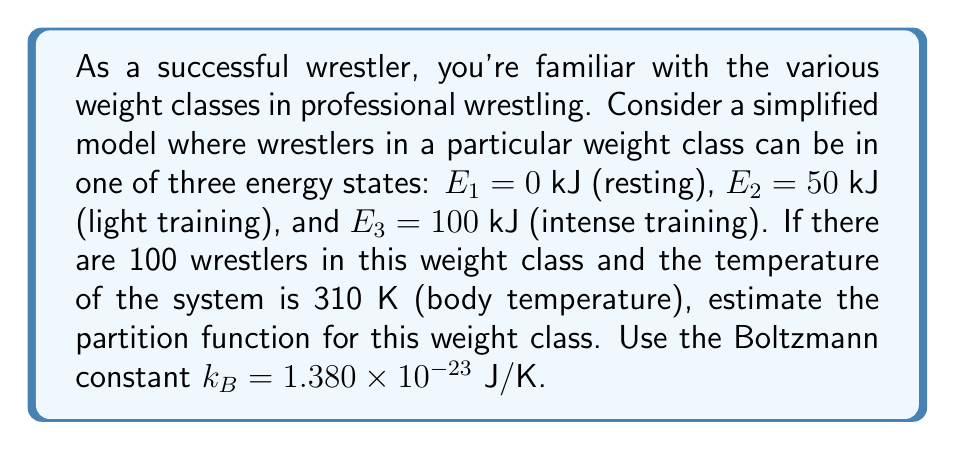Solve this math problem. Let's approach this step-by-step:

1) The partition function Z is given by:

   $$Z = \sum_i g_i e^{-E_i/k_BT}$$

   where $g_i$ is the degeneracy of each state (in this case, the number of wrestlers that can be in each state).

2) We have three energy states:
   $E_1 = 0$ kJ, $E_2 = 50$ kJ, $E_3 = 100$ kJ

3) Convert kJ to J:
   $E_1 = 0$ J, $E_2 = 50,000$ J, $E_3 = 100,000$ J

4) Given:
   $T = 310$ K
   $k_B = 1.380 \times 10^{-23}$ J/K

5) Calculate $k_BT$:
   $$k_BT = (1.380 \times 10^{-23} \text{ J/K})(310 \text{ K}) = 4.278 \times 10^{-21} \text{ J}$$

6) Now, let's calculate each term of the partition function:

   For $E_1$: $e^{-E_1/k_BT} = e^0 = 1$
   For $E_2$: $e^{-E_2/k_BT} = e^{-50,000 / (4.278 \times 10^{-21})} = e^{-1.169 \times 10^{25}} \approx 0$
   For $E_3$: $e^{-E_3/k_BT} = e^{-100,000 / (4.278 \times 10^{-21})} = e^{-2.338 \times 10^{25}} \approx 0$

7) Since there are 100 wrestlers total, and practically all of them will be in the lowest energy state due to the large energy differences, we can approximate:

   $$Z \approx 100 \cdot 1 + 0 + 0 = 100$$
Answer: $Z \approx 100$ 